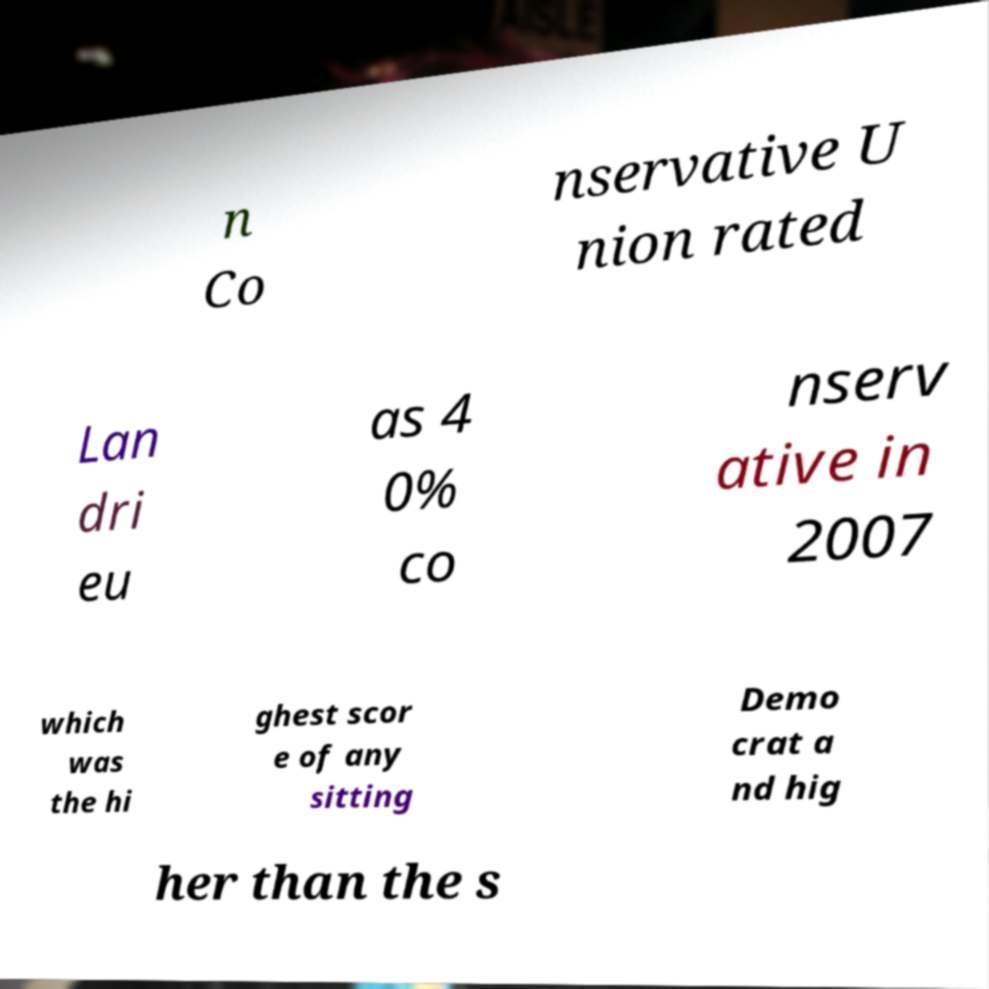Could you extract and type out the text from this image? n Co nservative U nion rated Lan dri eu as 4 0% co nserv ative in 2007 which was the hi ghest scor e of any sitting Demo crat a nd hig her than the s 